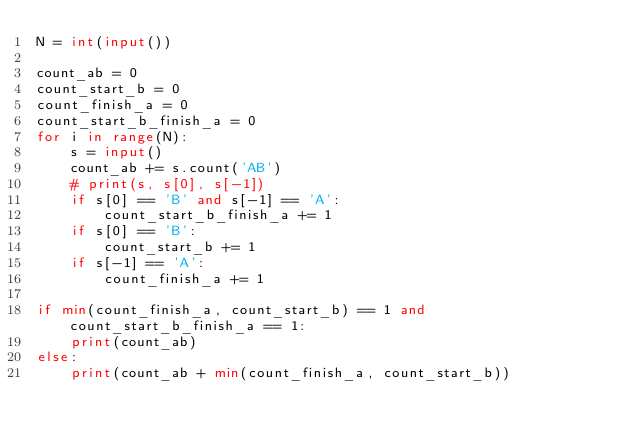Convert code to text. <code><loc_0><loc_0><loc_500><loc_500><_Python_>N = int(input())

count_ab = 0
count_start_b = 0
count_finish_a = 0
count_start_b_finish_a = 0
for i in range(N):
    s = input()
    count_ab += s.count('AB')
    # print(s, s[0], s[-1])
    if s[0] == 'B' and s[-1] == 'A':
        count_start_b_finish_a += 1
    if s[0] == 'B':
        count_start_b += 1
    if s[-1] == 'A':
        count_finish_a += 1

if min(count_finish_a, count_start_b) == 1 and count_start_b_finish_a == 1:
    print(count_ab)
else:
    print(count_ab + min(count_finish_a, count_start_b))</code> 